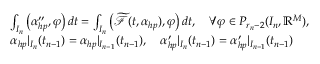<formula> <loc_0><loc_0><loc_500><loc_500>\begin{array} { r l } & { \int _ { I _ { n } } \left ( \alpha _ { h p } ^ { \prime \prime } , \varphi \right ) d t = \int _ { I _ { n } } \left ( \widetilde { \mathcal { F } } ( t , \alpha _ { h p } ) , \varphi \right ) d t , \quad \forall \varphi \in P _ { r _ { n } - 2 } ( I _ { n } , \mathbb { R } ^ { M } ) , } \\ & { \alpha _ { h p } | _ { I _ { n } } ( t _ { n - 1 } ) = \alpha _ { h p } | _ { I _ { n - 1 } } ( t _ { n - 1 } ) , \quad \alpha _ { h p } ^ { \prime } | _ { I _ { n } } ( t _ { n - 1 } ) = \alpha _ { h p } ^ { \prime } | _ { I _ { n - 1 } } ( t _ { n - 1 } ) } \end{array}</formula> 